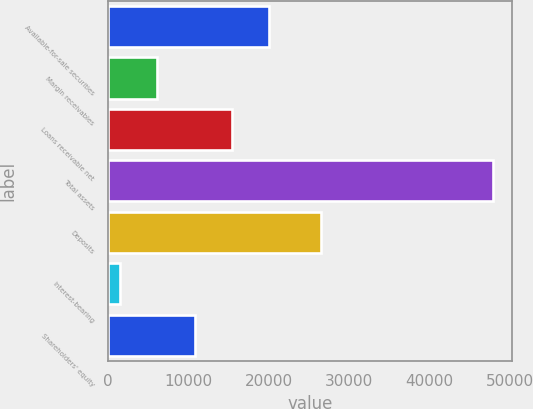<chart> <loc_0><loc_0><loc_500><loc_500><bar_chart><fcel>Available-for-sale securities<fcel>Margin receivables<fcel>Loans receivable net<fcel>Total assets<fcel>Deposits<fcel>Interest-bearing<fcel>Shareholders' equity<nl><fcel>20046.5<fcel>6099.5<fcel>15397.5<fcel>47940.5<fcel>26460<fcel>1450.5<fcel>10748.5<nl></chart> 